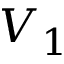Convert formula to latex. <formula><loc_0><loc_0><loc_500><loc_500>V _ { 1 }</formula> 